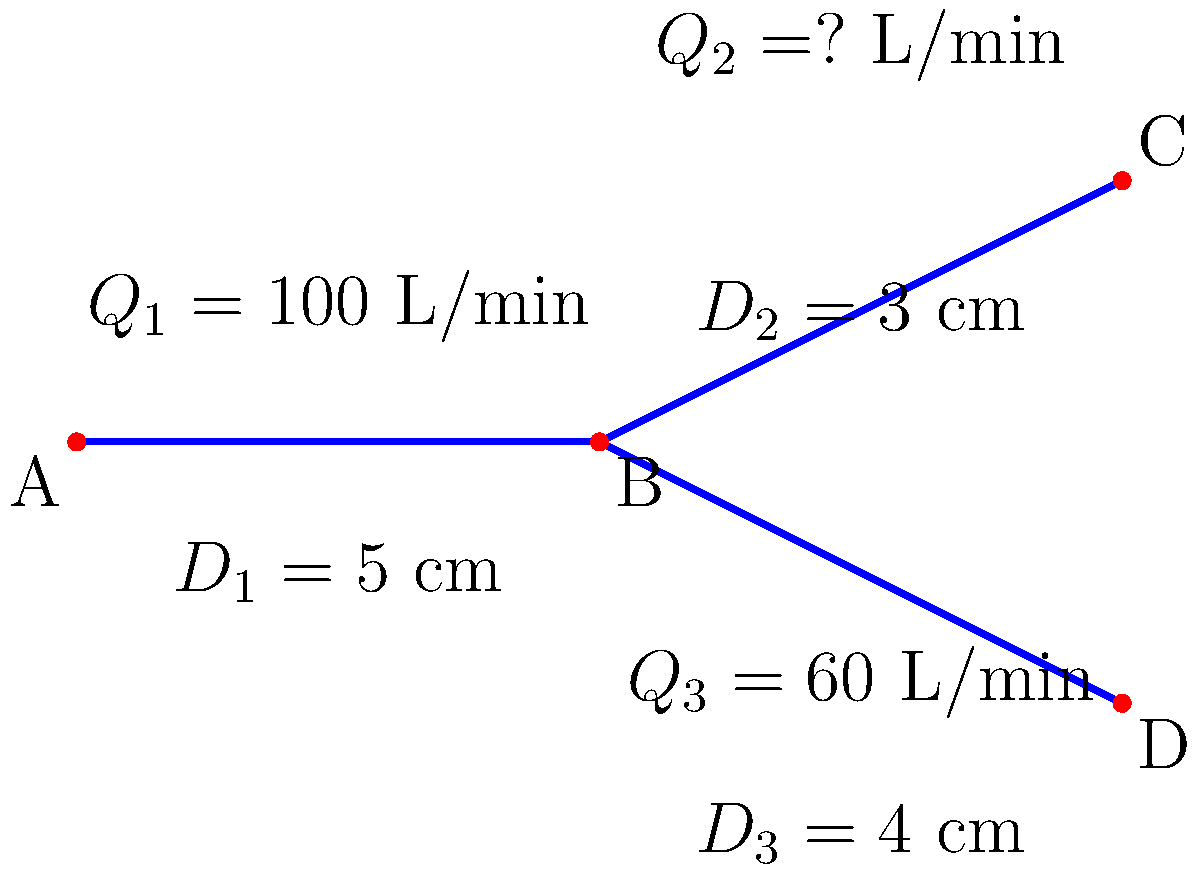As a food blogger reviewing online grocery delivery services, you've become curious about the water supply systems that support the farms producing your groceries. Consider the pipe network shown in the diagram, where water flows from point A to points C and D. Given that the flow rate at point A ($Q_1$) is 100 L/min, the flow rate to point D ($Q_3$) is 60 L/min, and the diameters of pipes 1, 2, and 3 are 5 cm, 3 cm, and 4 cm respectively, calculate the flow rate ($Q_2$) to point C in L/min. To solve this problem, we'll use the principle of conservation of mass (continuity equation) and the relationship between flow rate and pipe diameter. Let's break it down step-by-step:

1) First, apply the continuity equation at junction B:
   $Q_1 = Q_2 + Q_3$

2) We know $Q_1 = 100$ L/min and $Q_3 = 60$ L/min. Substitute these values:
   $100 = Q_2 + 60$

3) Solve for $Q_2$:
   $Q_2 = 100 - 60 = 40$ L/min

4) To verify this result, we can use the relationship between flow rate and pipe diameter. In a branching pipe system, the flow rate is proportional to the square of the diameter:
   $\frac{Q_2}{Q_3} = (\frac{D_2}{D_3})^2$

5) Substitute the known values:
   $\frac{Q_2}{60} = (\frac{3}{4})^2 = \frac{9}{16}$

6) Solve for $Q_2$:
   $Q_2 = 60 \cdot \frac{9}{16} = 33.75$ L/min

The slight discrepancy between this result and our initial calculation (40 L/min) is due to other factors like pressure differences and pipe roughness, which we didn't consider in our simplified model.

Therefore, the flow rate to point C ($Q_2$) is approximately 40 L/min.
Answer: 40 L/min 